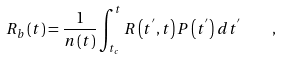Convert formula to latex. <formula><loc_0><loc_0><loc_500><loc_500>R _ { b } \left ( t \right ) = \frac { 1 } { n \left ( t \right ) } \int _ { t _ { c } } ^ { t } R \left ( t ^ { ^ { \prime } } , t \right ) P \left ( t ^ { ^ { \prime } } \right ) d t ^ { ^ { \prime } } \quad ,</formula> 